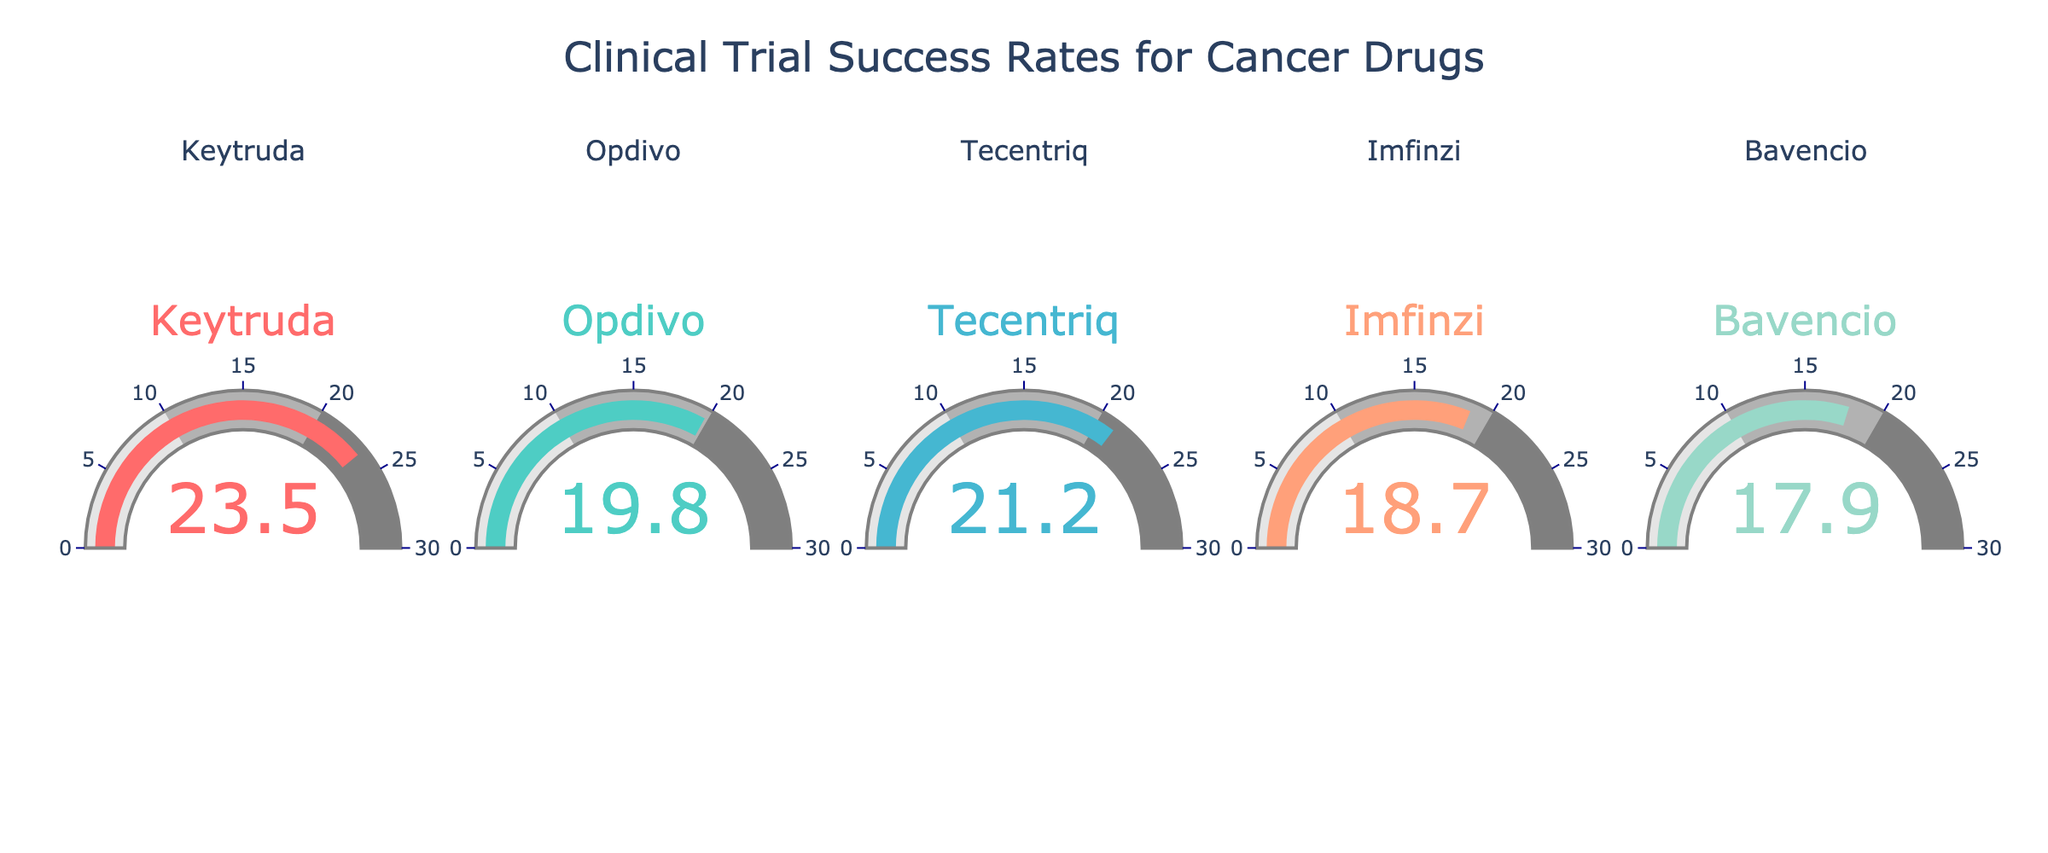What is the success rate for the drug Keytruda? The success rate for Keytruda is directly shown on the gauge chart associated with Keytruda.
Answer: 23.5% What is the difference in success rates between Tecentriq and Bavencio? According to the gauge charts, Tecentriq has a success rate of 21.2% and Bavencio has a success rate of 17.9%. The difference is calculated as 21.2% - 17.9% = 3.3%.
Answer: 3.3% Which drug has the lowest clinical trial success rate? By observing the gauge charts, you can see that Bavencio has the lowest success rate of 17.9%.
Answer: Bavencio What is the average success rate of all the drugs depicted? The success rates are Keytruda: 23.5%, Opdivo: 19.8%, Tecentriq: 21.2%, Imfinzi: 18.7%, and Bavencio: 17.9%. Summing these and dividing by 5 gives (23.5 + 19.8 + 21.2 + 18.7 + 17.9) / 5 = 20.22%.
Answer: 20.22% Which drug has a success rate closest to 20%? From the shown values, Opdivo has a success rate of 19.8%, which is closest to 20%.
Answer: Opdivo Is there any drug with more than a 25% success rate? None of the gauge charts show a success rate above 25%.
Answer: No What is the total success rate sum of all drugs? The success rates are Keytruda: 23.5%, Opdivo: 19.8%, Tecentriq: 21.2%, Imfinzi: 18.7%, and Bavencio: 17.9%. Summing these rates gives 23.5 + 19.8 + 21.2 + 18.7 + 17.9 = 101.1%.
Answer: 101.1% Is Imfinzi's success rate higher than Tecentriq's? Imfinzi has a success rate of 18.7%, while Tecentriq has a success rate of 21.2%. Therefore, Imfinzi's rate is not higher.
Answer: No What is the range of success rates among these drugs? The highest success rate is Keytruda at 23.5% and the lowest is Bavencio at 17.9%. The range is 23.5% - 17.9% = 5.6%.
Answer: 5.6% 